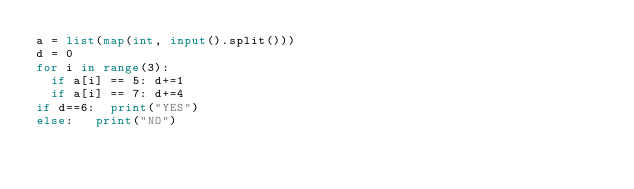Convert code to text. <code><loc_0><loc_0><loc_500><loc_500><_Python_>a = list(map(int, input().split()))
d = 0
for i in range(3):
	if a[i] == 5:	d+=1
	if a[i] == 7:	d+=4
if d==6:	print("YES")
else:		print("NO")</code> 